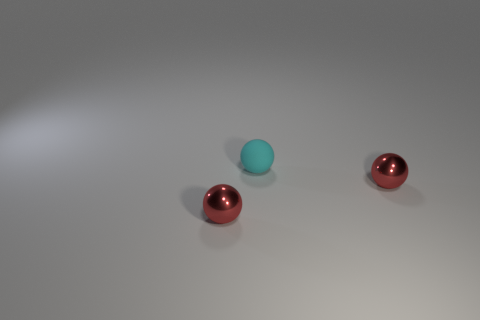How many red spheres must be subtracted to get 1 red spheres? 1 Subtract all tiny red shiny balls. How many balls are left? 1 Subtract all brown cylinders. How many red balls are left? 2 Subtract all cyan spheres. How many spheres are left? 2 Add 3 small cyan spheres. How many objects exist? 6 Subtract 2 balls. How many balls are left? 1 Subtract all yellow balls. Subtract all green cylinders. How many balls are left? 3 Subtract all cyan matte objects. Subtract all matte objects. How many objects are left? 1 Add 1 red metallic objects. How many red metallic objects are left? 3 Add 3 cyan matte spheres. How many cyan matte spheres exist? 4 